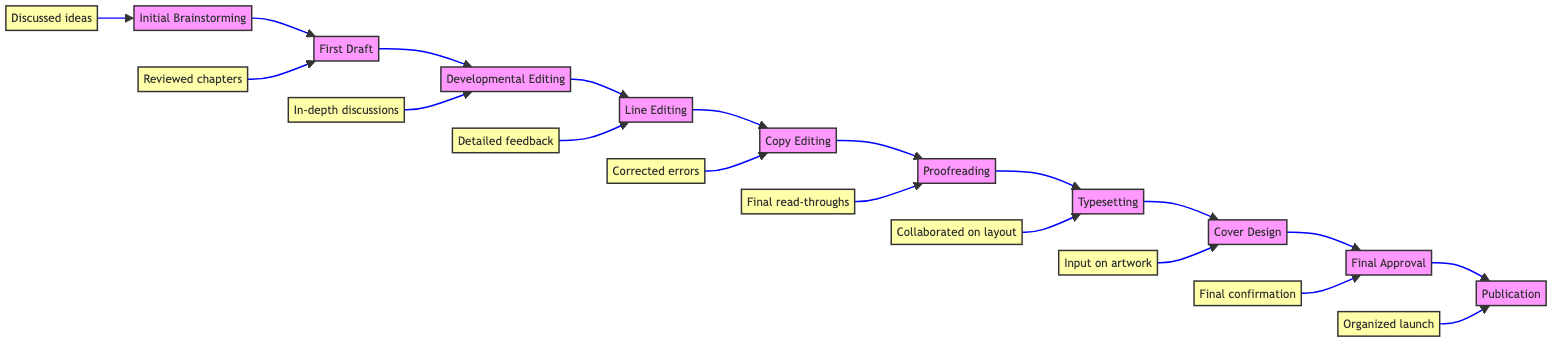What is the first step in the manuscript evolution process? The diagram shows that the first step is "Initial Brainstorming." This can be found at the leftmost part of the flowchart, indicating the starting point of the process.
Answer: Initial Brainstorming What follows after the First Draft? In the flowchart, "Developmental Editing" is the step that comes after "First Draft." It can be identified by looking at the directional arrows flowing from "First Draft" to the next box.
Answer: Developmental Editing How many total steps are there in the manuscript evolution process? By counting all the unique steps in the diagram from "Initial Brainstorming" to "Publication," you find that there are ten steps in total.
Answer: 10 What type of editing focuses on grammar and punctuation? According to the diagram, "Copy Editing" is the step dedicated to correcting grammar, punctuation, and syntax errors, as detailed in the description of that specific step.
Answer: Copy Editing Which editing step involves in-depth discussions with the author? The diagram indicates that "Developmental Editing" is the step that involves in-depth discussions with the author, as stated in the action connected to that step.
Answer: Developmental Editing In what step do authors receive detailed line-by-line feedback? The flowchart specifies that "Line Editing" is the stage where authors receive detailed line-by-line feedback to ensure clarity and consistency in the manuscript.
Answer: Line Editing What is the last step before the book is published? The diagram highlights "Final Approval" as the step immediately preceding "Publication," which is shown by the direct flow from "Final Approval" to "Publication."
Answer: Final Approval Which tools are mentioned for typesetting the manuscript? The diagram lists "Adobe InDesign" and "Vellum" as the tools associated with the "Typesetting" step, describing the formatting actions taken at this stage.
Answer: Adobe InDesign, Vellum What action is taken during the Proofreading step? In the diagram, the action described during "Proofreading" involves performing final read-throughs to catch overlooked typographical errors, emphasizing the importance of this step.
Answer: Final read-throughs 